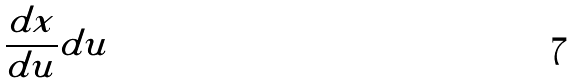Convert formula to latex. <formula><loc_0><loc_0><loc_500><loc_500>\frac { d x } { d u } d u</formula> 